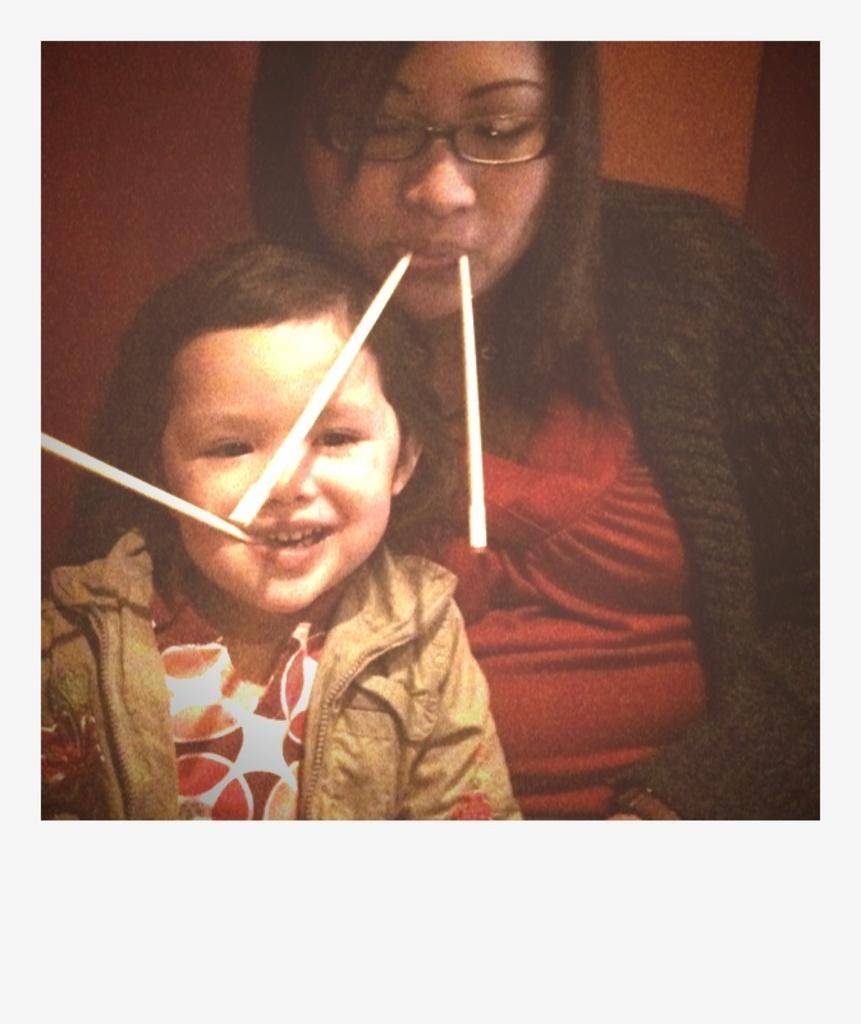Who is present in the image? There is a woman and a girl in the image. What are the woman and the girl doing in the image? The woman and the girl are sitting. What are they holding in their mouths? The woman and the girl are holding straws in their mouths. Where are the beds located in the image? There are no beds present in the image. Can you see a monkey in the image? There is no monkey present in the image. 